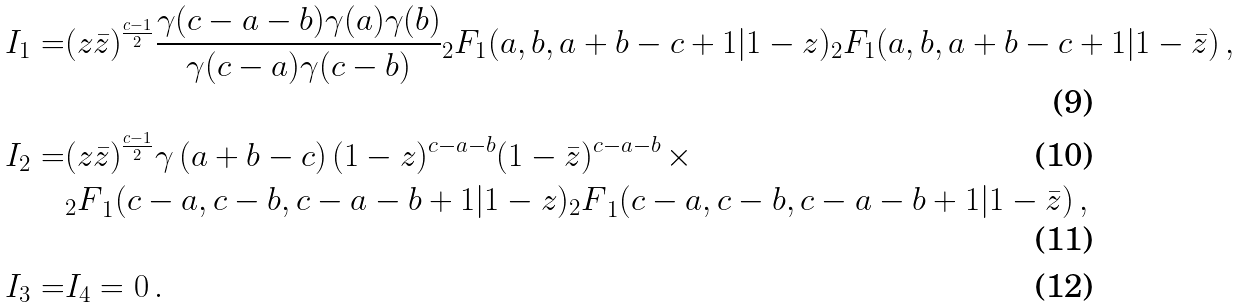<formula> <loc_0><loc_0><loc_500><loc_500>I _ { 1 } = & ( z \bar { z } ) ^ { \frac { c - 1 } { 2 } } \frac { \gamma ( c - a - b ) \gamma ( a ) \gamma ( b ) } { \gamma ( c - a ) \gamma ( c - b ) } { _ { 2 } F _ { 1 } } ( a , b , a + b - c + 1 | 1 - z ) { _ { 2 } F _ { 1 } } ( a , b , a + b - c + 1 | 1 - \bar { z } ) \, , \\ I _ { 2 } = & ( z \bar { z } ) ^ { \frac { c - 1 } { 2 } } \gamma \left ( a + b - c \right ) ( 1 - z ) ^ { c - a - b } ( 1 - \bar { z } ) ^ { c - a - b } \, \times \\ & { _ { 2 } F } _ { 1 } ( c - a , c - b , c - a - b + 1 | 1 - z ) { _ { 2 } F } _ { 1 } ( c - a , c - b , c - a - b + 1 | 1 - \bar { z } ) \, , \\ I _ { 3 } = & I _ { 4 } = 0 \, .</formula> 